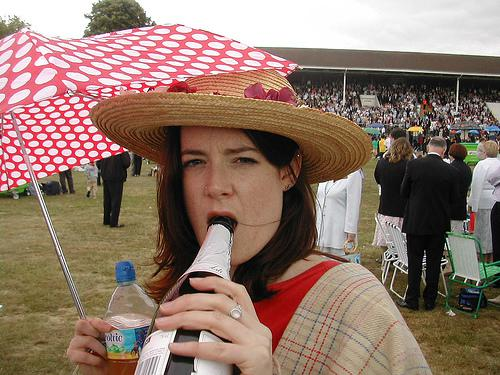Question: what color is the umbrella?
Choices:
A. Black.
B. Blue with white stripes.
C. Yellow.
D. Red and white polka dot.
Answer with the letter. Answer: D Question: what is the woman drinking?
Choices:
A. Champagne.
B. Wine.
C. Grape Juice.
D. Seltzer water.
Answer with the letter. Answer: A Question: where are the pink flowers on the woman?
Choices:
A. On her hat.
B. On her head.
C. In a ribbon on her head.
D. On her shirt.
Answer with the letter. Answer: A Question: where is this picture taken?
Choices:
A. A wedding.
B. A service.
C. A ceremony.
D. A church.
Answer with the letter. Answer: C 